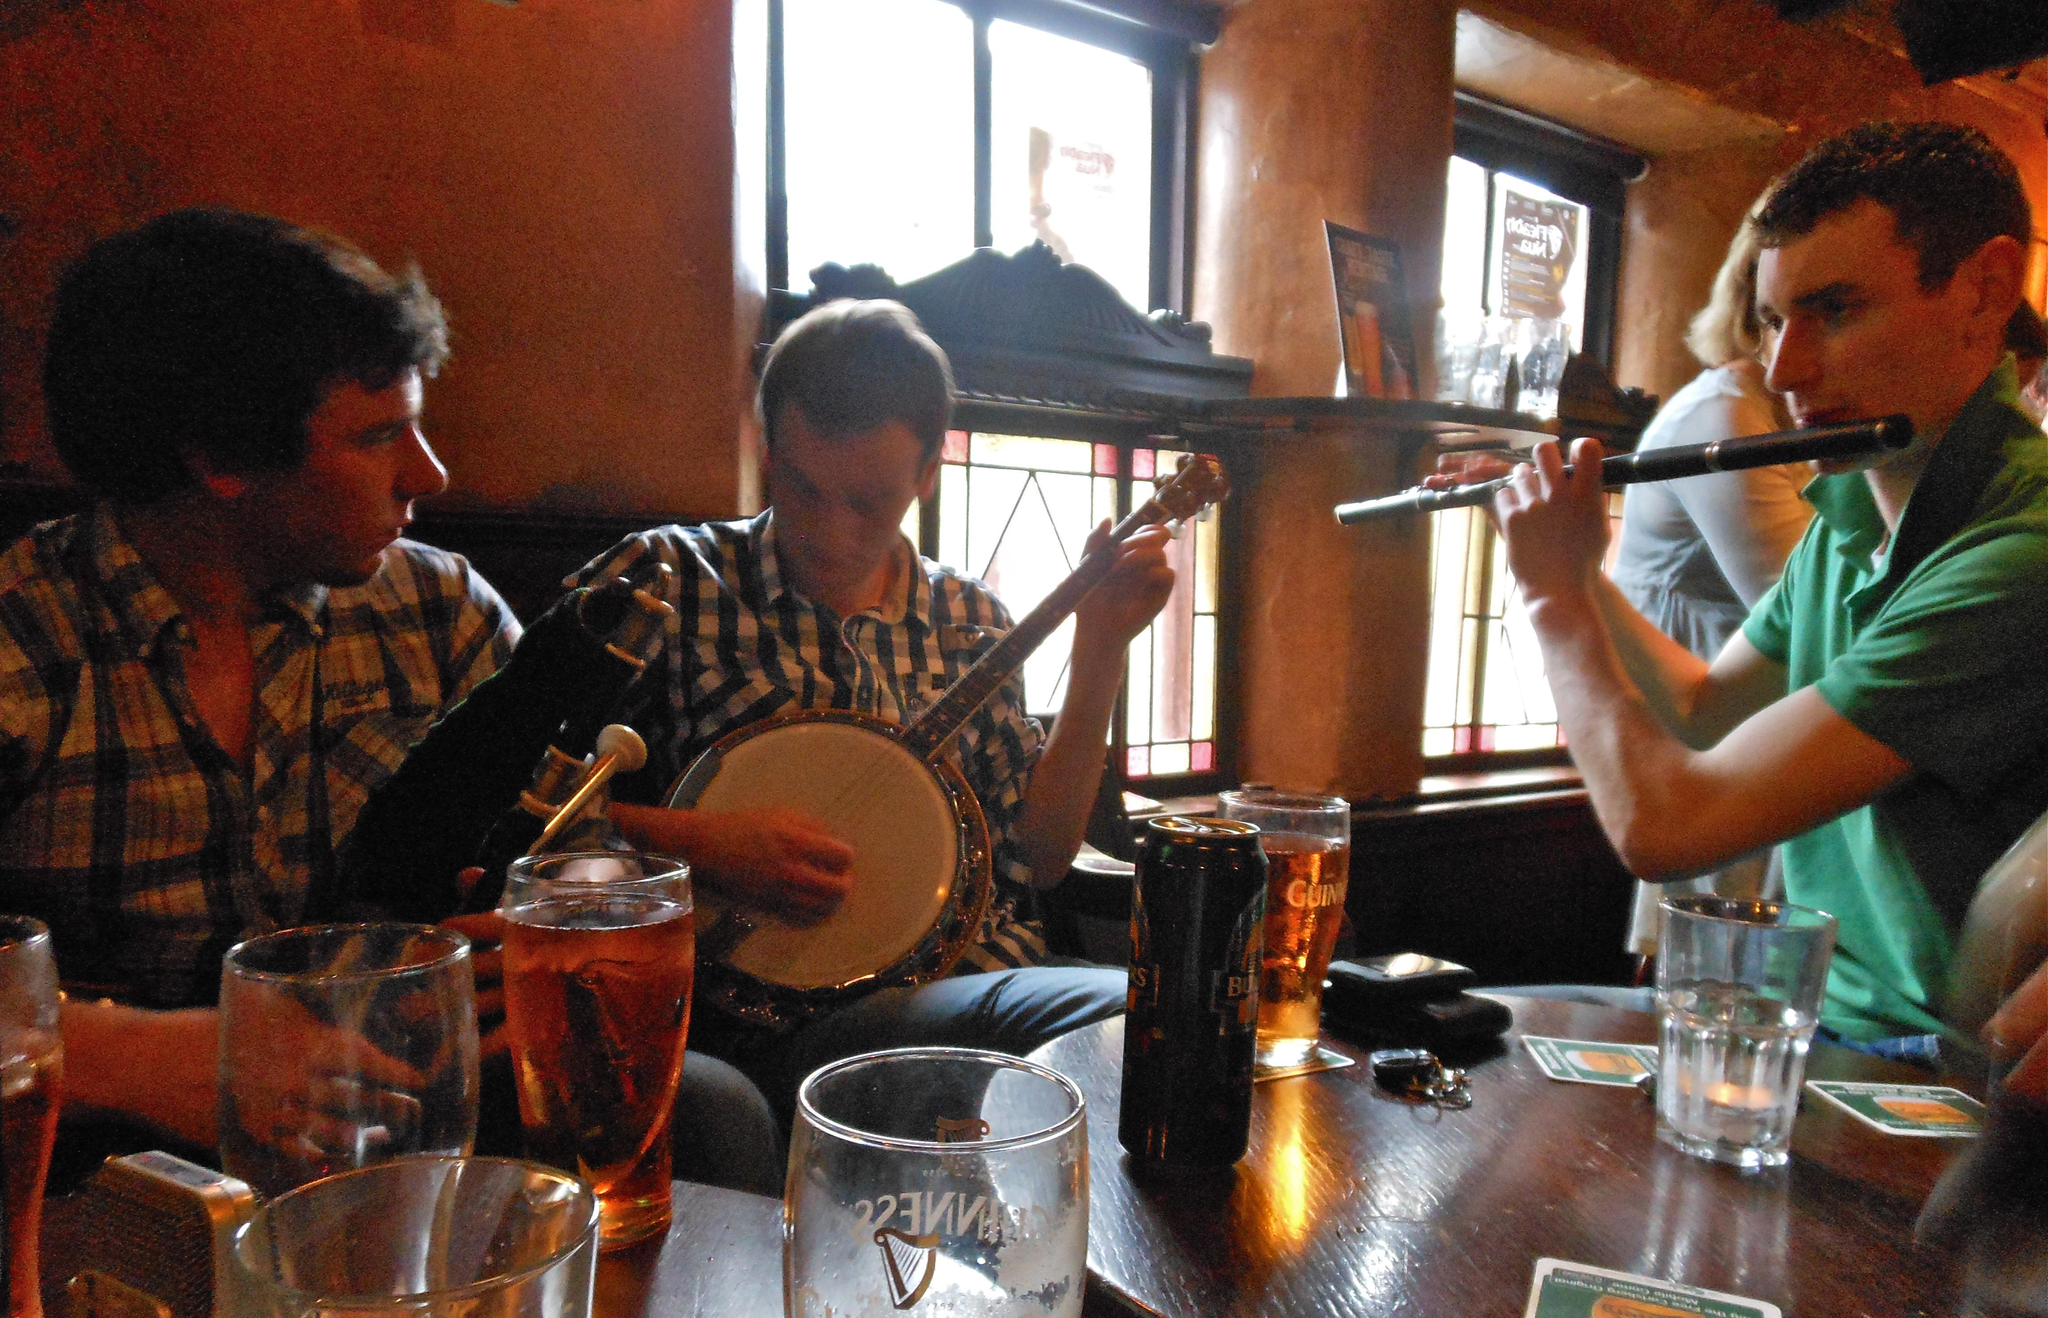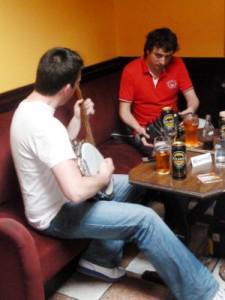The first image is the image on the left, the second image is the image on the right. For the images shown, is this caption "Two people are playing the flute." true? Answer yes or no. No. The first image is the image on the left, the second image is the image on the right. Examine the images to the left and right. Is the description "There are five people with instruments." accurate? Answer yes or no. Yes. 